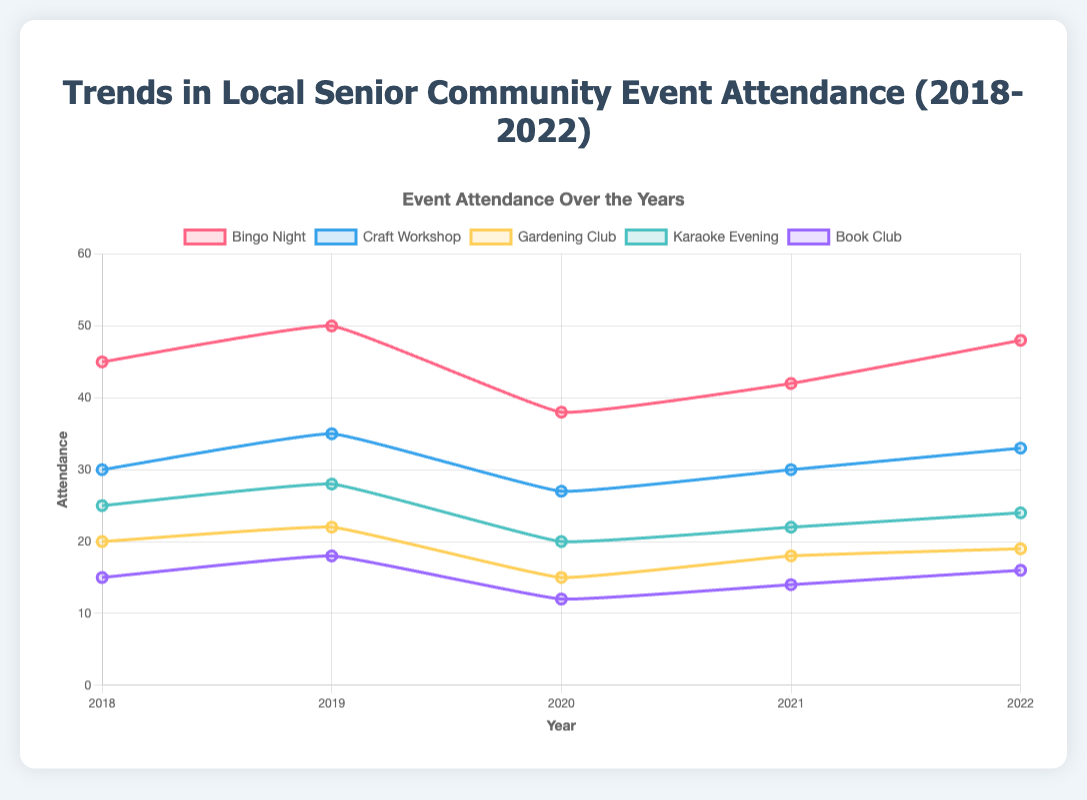What's the change in attendance for Bingo Night from 2018 to 2020? To find the change, subtract the attendance in 2020 from the attendance in 2018. The attendance for Bingo Night in 2018 was 45 and in 2020 it was 38. The change is 45 - 38 = 7
Answer: 7 Which event had the highest attendance in 2022? Look at the attendance figures for 2022 across all events. Bingo Night had the highest attendance with 48 attendees.
Answer: Bingo Night How did the attendance for the Craft Workshop change from 2019 to 2021? Subtract the attendance in 2021 from the attendance in 2019. In 2019, the attendance was 35 and in 2021, it was 30. The change is 35 - 30 = 5
Answer: 5 By how much did the attendance for Gardening Club decrease from 2019 to 2020? Subtract the attendance in 2020 from the attendance in 2019. The attendance for Gardening Club in 2019 was 22 and in 2020 it was 15. The decrease is 22 - 15 = 7
Answer: 7 Which event showed a consistent increase in attendance from 2020 to 2022? Look at the attendance trends for each event from 2020 to 2022. Bingo Night showed consistent increases: from 38 (2020) to 42 (2021) to 48 (2022).
Answer: Bingo Night What was the total attendance for Karaoke Evening in 2019 and 2020 combined? Add the attendance numbers for Karaoke Evening in 2019 and 2020. The attendance for Karaoke Evening was 28 in 2019 and 20 in 2020. The total is 28 + 20 = 48
Answer: 48 Which event had the smallest change in attendance between 2018 and 2022? Calculate the change for all events between 2018 and 2022 and compare. Gardening Club had the smallest change from 20 (2018) to 19 (2022), a change of 1.
Answer: Gardening Club What is the average attendance for Book Club over the five years? Add the attendance numbers for Book Club from 2018 to 2022 and divide by 5. The attendance numbers are 15 (2018), 18 (2019), 12 (2020), 14 (2021), and 16 (2022). The total is 15 + 18 + 12 + 14 + 16 = 75 and the average is 75 / 5 = 15
Answer: 15 Which two events had the exact same attendance figures in any given year? Compare the annual attendance figures for all event pairs. Karaoke Evening and Book Club had the same attendance in 2021 with both having 22 and 14 respectively.
Answer: Karaoke Evening, Book Club How did the total attendance for all events change between 2020 and 2021? Sum the total attendance for all events in both years and find the difference. For 2020: 38 + 27 + 15 + 20 + 12 = 112. For 2021: 42 + 30 + 18 + 22 + 14 = 126. The change is 126 - 112 = 14
Answer: 14 